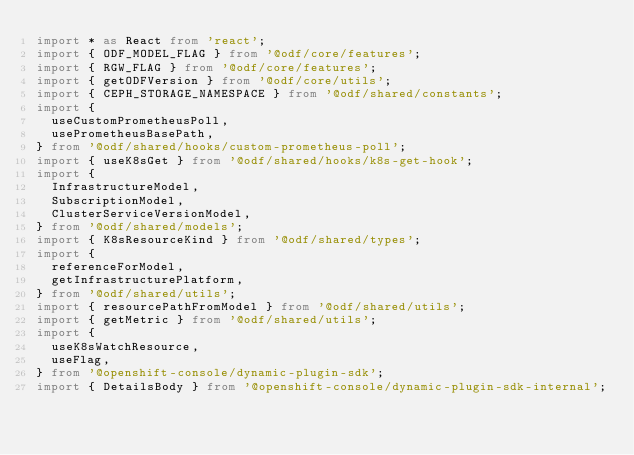<code> <loc_0><loc_0><loc_500><loc_500><_TypeScript_>import * as React from 'react';
import { ODF_MODEL_FLAG } from '@odf/core/features';
import { RGW_FLAG } from '@odf/core/features';
import { getODFVersion } from '@odf/core/utils';
import { CEPH_STORAGE_NAMESPACE } from '@odf/shared/constants';
import {
  useCustomPrometheusPoll,
  usePrometheusBasePath,
} from '@odf/shared/hooks/custom-prometheus-poll';
import { useK8sGet } from '@odf/shared/hooks/k8s-get-hook';
import {
  InfrastructureModel,
  SubscriptionModel,
  ClusterServiceVersionModel,
} from '@odf/shared/models';
import { K8sResourceKind } from '@odf/shared/types';
import {
  referenceForModel,
  getInfrastructurePlatform,
} from '@odf/shared/utils';
import { resourcePathFromModel } from '@odf/shared/utils';
import { getMetric } from '@odf/shared/utils';
import {
  useK8sWatchResource,
  useFlag,
} from '@openshift-console/dynamic-plugin-sdk';
import { DetailsBody } from '@openshift-console/dynamic-plugin-sdk-internal';</code> 